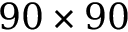Convert formula to latex. <formula><loc_0><loc_0><loc_500><loc_500>9 0 \times 9 0</formula> 